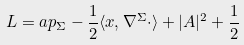Convert formula to latex. <formula><loc_0><loc_0><loc_500><loc_500>L = \L a p _ { \Sigma } - \frac { 1 } { 2 } \langle x , \nabla ^ { \Sigma } \cdot \rangle + | A | ^ { 2 } + \frac { 1 } { 2 }</formula> 